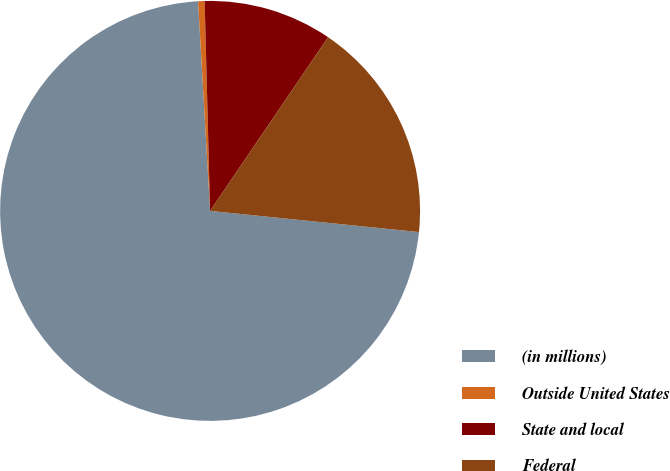<chart> <loc_0><loc_0><loc_500><loc_500><pie_chart><fcel>(in millions)<fcel>Outside United States<fcel>State and local<fcel>Federal<nl><fcel>72.48%<fcel>0.5%<fcel>9.91%<fcel>17.11%<nl></chart> 